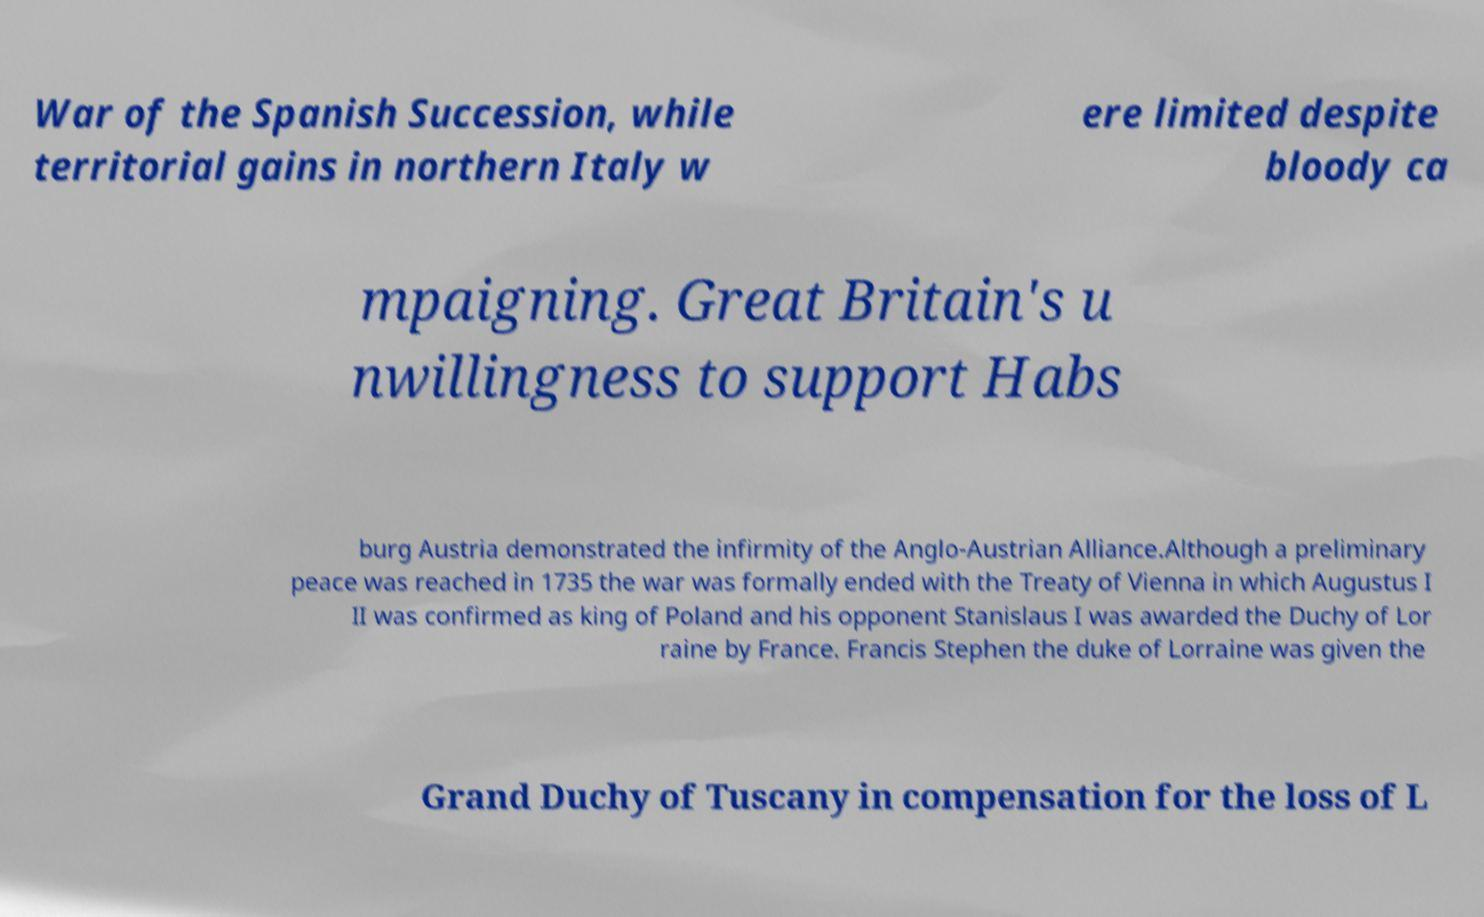Please identify and transcribe the text found in this image. War of the Spanish Succession, while territorial gains in northern Italy w ere limited despite bloody ca mpaigning. Great Britain's u nwillingness to support Habs burg Austria demonstrated the infirmity of the Anglo-Austrian Alliance.Although a preliminary peace was reached in 1735 the war was formally ended with the Treaty of Vienna in which Augustus I II was confirmed as king of Poland and his opponent Stanislaus I was awarded the Duchy of Lor raine by France. Francis Stephen the duke of Lorraine was given the Grand Duchy of Tuscany in compensation for the loss of L 